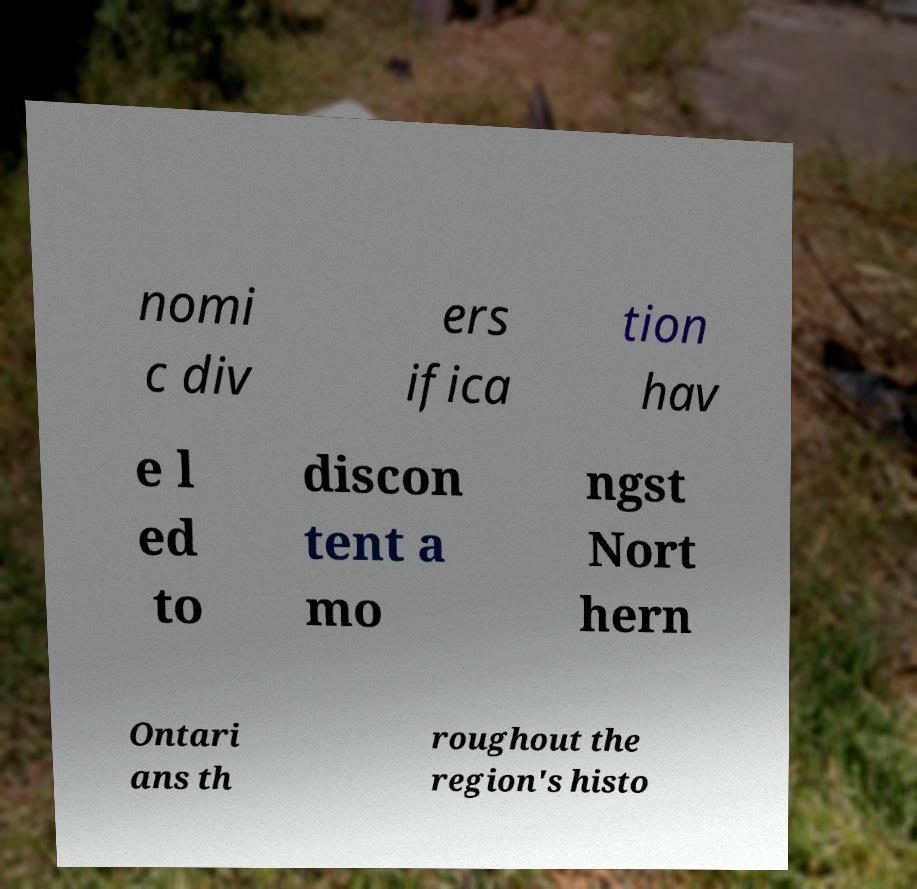For documentation purposes, I need the text within this image transcribed. Could you provide that? nomi c div ers ifica tion hav e l ed to discon tent a mo ngst Nort hern Ontari ans th roughout the region's histo 